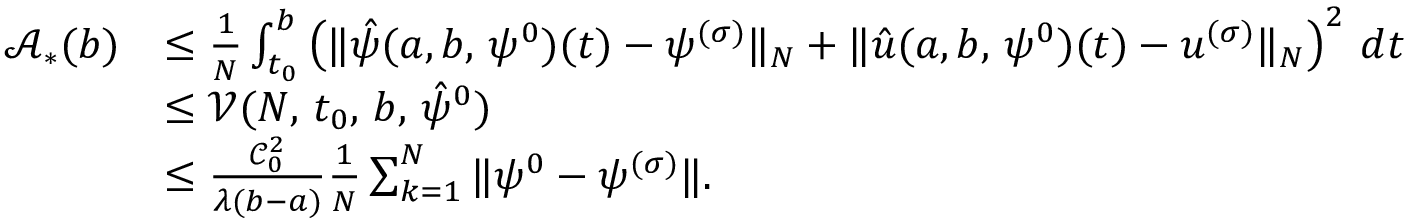Convert formula to latex. <formula><loc_0><loc_0><loc_500><loc_500>\begin{array} { r l } { \mathcal { A } _ { \ast } ( b ) } & { \leq { \frac { 1 } { N } \int _ { t _ { 0 } } ^ { b } \left ( \| \hat { \psi } ( a , b , \, \psi ^ { 0 } ) ( t ) - \psi ^ { ( \sigma ) } \| _ { N } + \| \hat { u } ( a , b , \, \psi ^ { 0 } ) ( t ) - u ^ { ( \sigma ) } \| _ { N } \right ) ^ { 2 } \, d t } } \\ & { \leq \mathcal { V } ( N , \, t _ { 0 } , \, b , \, \hat { \psi } ^ { 0 } ) } \\ & { \leq \frac { \mathcal { C } _ { 0 } ^ { 2 } } { \lambda ( b - a ) } \frac { 1 } { N } \sum _ { k = 1 } ^ { N } \| \psi ^ { 0 } - \psi ^ { ( \sigma ) } \| . } \end{array}</formula> 